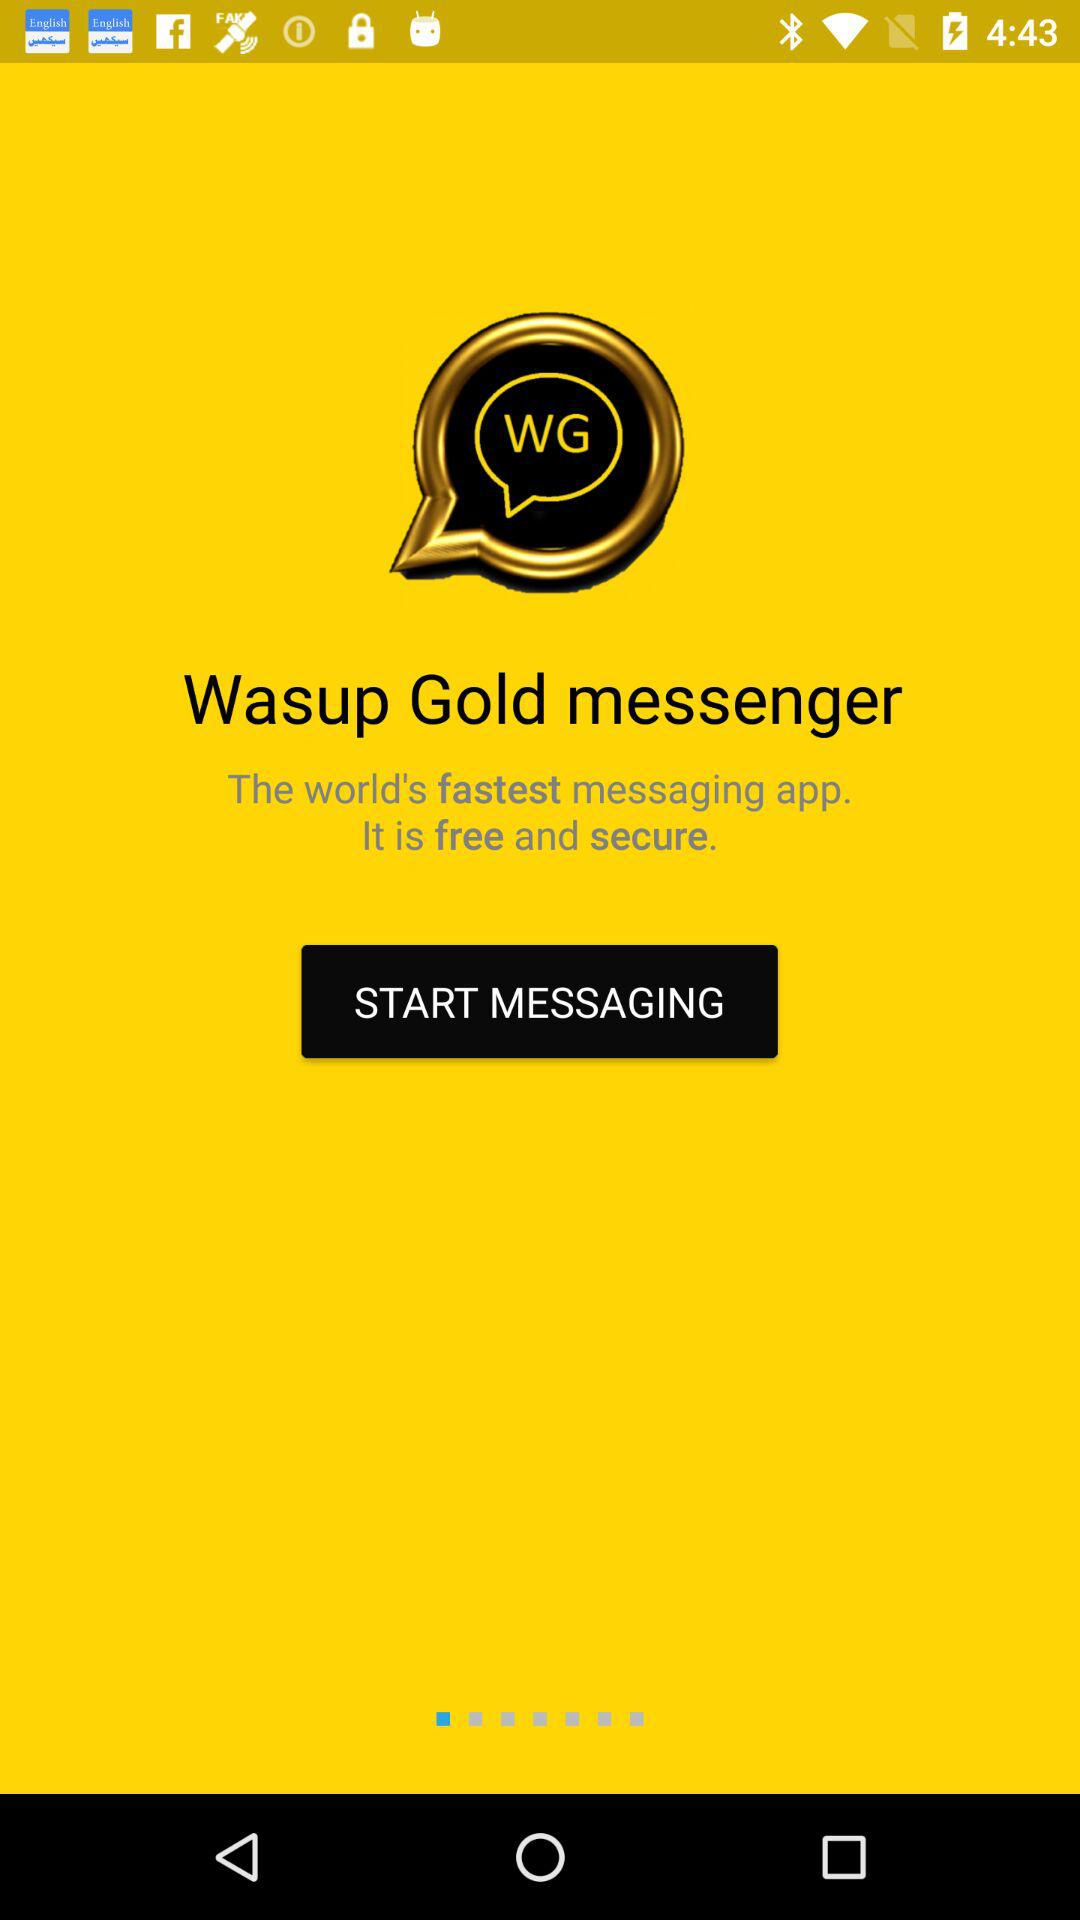What is the application name? The application name is "Wasup Gold messenger". 